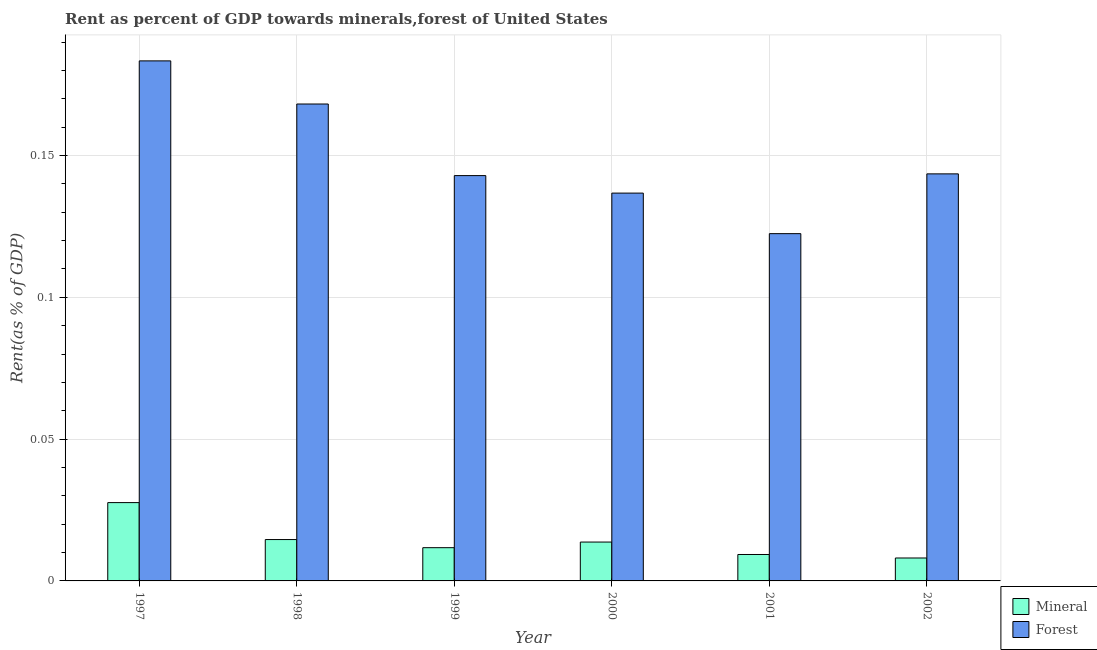Are the number of bars per tick equal to the number of legend labels?
Give a very brief answer. Yes. What is the label of the 1st group of bars from the left?
Your answer should be compact. 1997. What is the forest rent in 2000?
Offer a terse response. 0.14. Across all years, what is the maximum forest rent?
Offer a terse response. 0.18. Across all years, what is the minimum mineral rent?
Ensure brevity in your answer.  0.01. In which year was the forest rent minimum?
Make the answer very short. 2001. What is the total forest rent in the graph?
Offer a very short reply. 0.9. What is the difference between the mineral rent in 1997 and that in 2001?
Your answer should be compact. 0.02. What is the difference between the forest rent in 1998 and the mineral rent in 1999?
Your answer should be very brief. 0.03. What is the average mineral rent per year?
Give a very brief answer. 0.01. In the year 1998, what is the difference between the forest rent and mineral rent?
Ensure brevity in your answer.  0. What is the ratio of the forest rent in 1997 to that in 1998?
Your response must be concise. 1.09. What is the difference between the highest and the second highest forest rent?
Your response must be concise. 0.02. What is the difference between the highest and the lowest mineral rent?
Provide a succinct answer. 0.02. In how many years, is the mineral rent greater than the average mineral rent taken over all years?
Your answer should be very brief. 2. What does the 1st bar from the left in 1999 represents?
Your response must be concise. Mineral. What does the 2nd bar from the right in 2001 represents?
Provide a short and direct response. Mineral. Does the graph contain any zero values?
Your answer should be very brief. No. Does the graph contain grids?
Ensure brevity in your answer.  Yes. Where does the legend appear in the graph?
Offer a terse response. Bottom right. How are the legend labels stacked?
Your answer should be compact. Vertical. What is the title of the graph?
Your answer should be very brief. Rent as percent of GDP towards minerals,forest of United States. What is the label or title of the Y-axis?
Provide a succinct answer. Rent(as % of GDP). What is the Rent(as % of GDP) of Mineral in 1997?
Give a very brief answer. 0.03. What is the Rent(as % of GDP) in Forest in 1997?
Provide a short and direct response. 0.18. What is the Rent(as % of GDP) of Mineral in 1998?
Provide a succinct answer. 0.01. What is the Rent(as % of GDP) of Forest in 1998?
Offer a very short reply. 0.17. What is the Rent(as % of GDP) in Mineral in 1999?
Ensure brevity in your answer.  0.01. What is the Rent(as % of GDP) in Forest in 1999?
Provide a succinct answer. 0.14. What is the Rent(as % of GDP) of Mineral in 2000?
Offer a very short reply. 0.01. What is the Rent(as % of GDP) of Forest in 2000?
Keep it short and to the point. 0.14. What is the Rent(as % of GDP) of Mineral in 2001?
Offer a terse response. 0.01. What is the Rent(as % of GDP) of Forest in 2001?
Provide a short and direct response. 0.12. What is the Rent(as % of GDP) in Mineral in 2002?
Provide a short and direct response. 0.01. What is the Rent(as % of GDP) of Forest in 2002?
Your response must be concise. 0.14. Across all years, what is the maximum Rent(as % of GDP) in Mineral?
Ensure brevity in your answer.  0.03. Across all years, what is the maximum Rent(as % of GDP) of Forest?
Offer a very short reply. 0.18. Across all years, what is the minimum Rent(as % of GDP) of Mineral?
Ensure brevity in your answer.  0.01. Across all years, what is the minimum Rent(as % of GDP) in Forest?
Offer a terse response. 0.12. What is the total Rent(as % of GDP) of Mineral in the graph?
Ensure brevity in your answer.  0.09. What is the total Rent(as % of GDP) of Forest in the graph?
Provide a succinct answer. 0.9. What is the difference between the Rent(as % of GDP) in Mineral in 1997 and that in 1998?
Your answer should be very brief. 0.01. What is the difference between the Rent(as % of GDP) in Forest in 1997 and that in 1998?
Offer a terse response. 0.02. What is the difference between the Rent(as % of GDP) of Mineral in 1997 and that in 1999?
Offer a terse response. 0.02. What is the difference between the Rent(as % of GDP) of Forest in 1997 and that in 1999?
Offer a very short reply. 0.04. What is the difference between the Rent(as % of GDP) of Mineral in 1997 and that in 2000?
Offer a terse response. 0.01. What is the difference between the Rent(as % of GDP) in Forest in 1997 and that in 2000?
Your answer should be compact. 0.05. What is the difference between the Rent(as % of GDP) of Mineral in 1997 and that in 2001?
Keep it short and to the point. 0.02. What is the difference between the Rent(as % of GDP) of Forest in 1997 and that in 2001?
Provide a succinct answer. 0.06. What is the difference between the Rent(as % of GDP) of Mineral in 1997 and that in 2002?
Offer a very short reply. 0.02. What is the difference between the Rent(as % of GDP) in Forest in 1997 and that in 2002?
Keep it short and to the point. 0.04. What is the difference between the Rent(as % of GDP) in Mineral in 1998 and that in 1999?
Give a very brief answer. 0. What is the difference between the Rent(as % of GDP) in Forest in 1998 and that in 1999?
Offer a very short reply. 0.03. What is the difference between the Rent(as % of GDP) of Mineral in 1998 and that in 2000?
Your response must be concise. 0. What is the difference between the Rent(as % of GDP) of Forest in 1998 and that in 2000?
Provide a succinct answer. 0.03. What is the difference between the Rent(as % of GDP) in Mineral in 1998 and that in 2001?
Your answer should be compact. 0.01. What is the difference between the Rent(as % of GDP) of Forest in 1998 and that in 2001?
Your answer should be compact. 0.05. What is the difference between the Rent(as % of GDP) in Mineral in 1998 and that in 2002?
Your answer should be very brief. 0.01. What is the difference between the Rent(as % of GDP) in Forest in 1998 and that in 2002?
Ensure brevity in your answer.  0.02. What is the difference between the Rent(as % of GDP) of Mineral in 1999 and that in 2000?
Offer a very short reply. -0. What is the difference between the Rent(as % of GDP) of Forest in 1999 and that in 2000?
Keep it short and to the point. 0.01. What is the difference between the Rent(as % of GDP) in Mineral in 1999 and that in 2001?
Your answer should be very brief. 0. What is the difference between the Rent(as % of GDP) in Forest in 1999 and that in 2001?
Offer a very short reply. 0.02. What is the difference between the Rent(as % of GDP) in Mineral in 1999 and that in 2002?
Make the answer very short. 0. What is the difference between the Rent(as % of GDP) of Forest in 1999 and that in 2002?
Make the answer very short. -0. What is the difference between the Rent(as % of GDP) of Mineral in 2000 and that in 2001?
Ensure brevity in your answer.  0. What is the difference between the Rent(as % of GDP) in Forest in 2000 and that in 2001?
Make the answer very short. 0.01. What is the difference between the Rent(as % of GDP) of Mineral in 2000 and that in 2002?
Your answer should be compact. 0.01. What is the difference between the Rent(as % of GDP) in Forest in 2000 and that in 2002?
Provide a succinct answer. -0.01. What is the difference between the Rent(as % of GDP) of Mineral in 2001 and that in 2002?
Give a very brief answer. 0. What is the difference between the Rent(as % of GDP) in Forest in 2001 and that in 2002?
Ensure brevity in your answer.  -0.02. What is the difference between the Rent(as % of GDP) in Mineral in 1997 and the Rent(as % of GDP) in Forest in 1998?
Your answer should be very brief. -0.14. What is the difference between the Rent(as % of GDP) in Mineral in 1997 and the Rent(as % of GDP) in Forest in 1999?
Ensure brevity in your answer.  -0.12. What is the difference between the Rent(as % of GDP) in Mineral in 1997 and the Rent(as % of GDP) in Forest in 2000?
Ensure brevity in your answer.  -0.11. What is the difference between the Rent(as % of GDP) of Mineral in 1997 and the Rent(as % of GDP) of Forest in 2001?
Provide a succinct answer. -0.09. What is the difference between the Rent(as % of GDP) in Mineral in 1997 and the Rent(as % of GDP) in Forest in 2002?
Provide a short and direct response. -0.12. What is the difference between the Rent(as % of GDP) of Mineral in 1998 and the Rent(as % of GDP) of Forest in 1999?
Give a very brief answer. -0.13. What is the difference between the Rent(as % of GDP) in Mineral in 1998 and the Rent(as % of GDP) in Forest in 2000?
Offer a terse response. -0.12. What is the difference between the Rent(as % of GDP) in Mineral in 1998 and the Rent(as % of GDP) in Forest in 2001?
Your answer should be very brief. -0.11. What is the difference between the Rent(as % of GDP) in Mineral in 1998 and the Rent(as % of GDP) in Forest in 2002?
Your answer should be very brief. -0.13. What is the difference between the Rent(as % of GDP) of Mineral in 1999 and the Rent(as % of GDP) of Forest in 2000?
Your response must be concise. -0.12. What is the difference between the Rent(as % of GDP) in Mineral in 1999 and the Rent(as % of GDP) in Forest in 2001?
Ensure brevity in your answer.  -0.11. What is the difference between the Rent(as % of GDP) in Mineral in 1999 and the Rent(as % of GDP) in Forest in 2002?
Your answer should be compact. -0.13. What is the difference between the Rent(as % of GDP) of Mineral in 2000 and the Rent(as % of GDP) of Forest in 2001?
Ensure brevity in your answer.  -0.11. What is the difference between the Rent(as % of GDP) in Mineral in 2000 and the Rent(as % of GDP) in Forest in 2002?
Provide a succinct answer. -0.13. What is the difference between the Rent(as % of GDP) in Mineral in 2001 and the Rent(as % of GDP) in Forest in 2002?
Provide a succinct answer. -0.13. What is the average Rent(as % of GDP) of Mineral per year?
Keep it short and to the point. 0.01. What is the average Rent(as % of GDP) in Forest per year?
Offer a terse response. 0.15. In the year 1997, what is the difference between the Rent(as % of GDP) in Mineral and Rent(as % of GDP) in Forest?
Provide a succinct answer. -0.16. In the year 1998, what is the difference between the Rent(as % of GDP) of Mineral and Rent(as % of GDP) of Forest?
Ensure brevity in your answer.  -0.15. In the year 1999, what is the difference between the Rent(as % of GDP) of Mineral and Rent(as % of GDP) of Forest?
Your response must be concise. -0.13. In the year 2000, what is the difference between the Rent(as % of GDP) of Mineral and Rent(as % of GDP) of Forest?
Provide a short and direct response. -0.12. In the year 2001, what is the difference between the Rent(as % of GDP) in Mineral and Rent(as % of GDP) in Forest?
Your answer should be compact. -0.11. In the year 2002, what is the difference between the Rent(as % of GDP) of Mineral and Rent(as % of GDP) of Forest?
Provide a succinct answer. -0.14. What is the ratio of the Rent(as % of GDP) in Mineral in 1997 to that in 1998?
Provide a succinct answer. 1.89. What is the ratio of the Rent(as % of GDP) in Forest in 1997 to that in 1998?
Your answer should be compact. 1.09. What is the ratio of the Rent(as % of GDP) of Mineral in 1997 to that in 1999?
Give a very brief answer. 2.36. What is the ratio of the Rent(as % of GDP) of Forest in 1997 to that in 1999?
Ensure brevity in your answer.  1.28. What is the ratio of the Rent(as % of GDP) of Mineral in 1997 to that in 2000?
Offer a very short reply. 2.02. What is the ratio of the Rent(as % of GDP) in Forest in 1997 to that in 2000?
Your response must be concise. 1.34. What is the ratio of the Rent(as % of GDP) in Mineral in 1997 to that in 2001?
Provide a short and direct response. 2.96. What is the ratio of the Rent(as % of GDP) of Forest in 1997 to that in 2001?
Provide a short and direct response. 1.5. What is the ratio of the Rent(as % of GDP) in Mineral in 1997 to that in 2002?
Offer a terse response. 3.42. What is the ratio of the Rent(as % of GDP) in Forest in 1997 to that in 2002?
Give a very brief answer. 1.28. What is the ratio of the Rent(as % of GDP) of Mineral in 1998 to that in 1999?
Make the answer very short. 1.24. What is the ratio of the Rent(as % of GDP) of Forest in 1998 to that in 1999?
Your answer should be very brief. 1.18. What is the ratio of the Rent(as % of GDP) in Mineral in 1998 to that in 2000?
Your answer should be compact. 1.06. What is the ratio of the Rent(as % of GDP) of Forest in 1998 to that in 2000?
Offer a very short reply. 1.23. What is the ratio of the Rent(as % of GDP) of Mineral in 1998 to that in 2001?
Your response must be concise. 1.57. What is the ratio of the Rent(as % of GDP) in Forest in 1998 to that in 2001?
Keep it short and to the point. 1.37. What is the ratio of the Rent(as % of GDP) of Mineral in 1998 to that in 2002?
Provide a succinct answer. 1.8. What is the ratio of the Rent(as % of GDP) in Forest in 1998 to that in 2002?
Give a very brief answer. 1.17. What is the ratio of the Rent(as % of GDP) of Mineral in 1999 to that in 2000?
Your answer should be compact. 0.86. What is the ratio of the Rent(as % of GDP) of Forest in 1999 to that in 2000?
Make the answer very short. 1.05. What is the ratio of the Rent(as % of GDP) in Mineral in 1999 to that in 2001?
Give a very brief answer. 1.26. What is the ratio of the Rent(as % of GDP) of Forest in 1999 to that in 2001?
Offer a very short reply. 1.17. What is the ratio of the Rent(as % of GDP) in Mineral in 1999 to that in 2002?
Your answer should be very brief. 1.45. What is the ratio of the Rent(as % of GDP) of Forest in 1999 to that in 2002?
Your answer should be compact. 1. What is the ratio of the Rent(as % of GDP) in Mineral in 2000 to that in 2001?
Offer a very short reply. 1.47. What is the ratio of the Rent(as % of GDP) of Forest in 2000 to that in 2001?
Your answer should be compact. 1.12. What is the ratio of the Rent(as % of GDP) of Mineral in 2000 to that in 2002?
Make the answer very short. 1.69. What is the ratio of the Rent(as % of GDP) in Forest in 2000 to that in 2002?
Ensure brevity in your answer.  0.95. What is the ratio of the Rent(as % of GDP) of Mineral in 2001 to that in 2002?
Offer a terse response. 1.15. What is the ratio of the Rent(as % of GDP) in Forest in 2001 to that in 2002?
Ensure brevity in your answer.  0.85. What is the difference between the highest and the second highest Rent(as % of GDP) in Mineral?
Offer a very short reply. 0.01. What is the difference between the highest and the second highest Rent(as % of GDP) of Forest?
Your answer should be compact. 0.02. What is the difference between the highest and the lowest Rent(as % of GDP) in Mineral?
Provide a succinct answer. 0.02. What is the difference between the highest and the lowest Rent(as % of GDP) of Forest?
Your response must be concise. 0.06. 